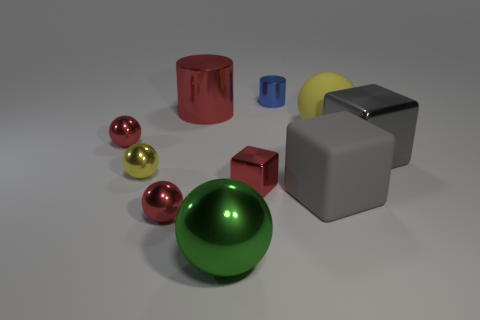How many red balls must be subtracted to get 1 red balls? 1 Subtract all cylinders. How many objects are left? 8 Add 2 gray cubes. How many gray cubes are left? 4 Add 1 tiny brown shiny things. How many tiny brown shiny things exist? 1 Subtract 0 yellow cylinders. How many objects are left? 10 Subtract all tiny blue shiny objects. Subtract all shiny things. How many objects are left? 1 